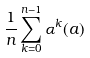<formula> <loc_0><loc_0><loc_500><loc_500>\frac { 1 } { n } \sum _ { k = 0 } ^ { n - 1 } \alpha ^ { k } ( a )</formula> 